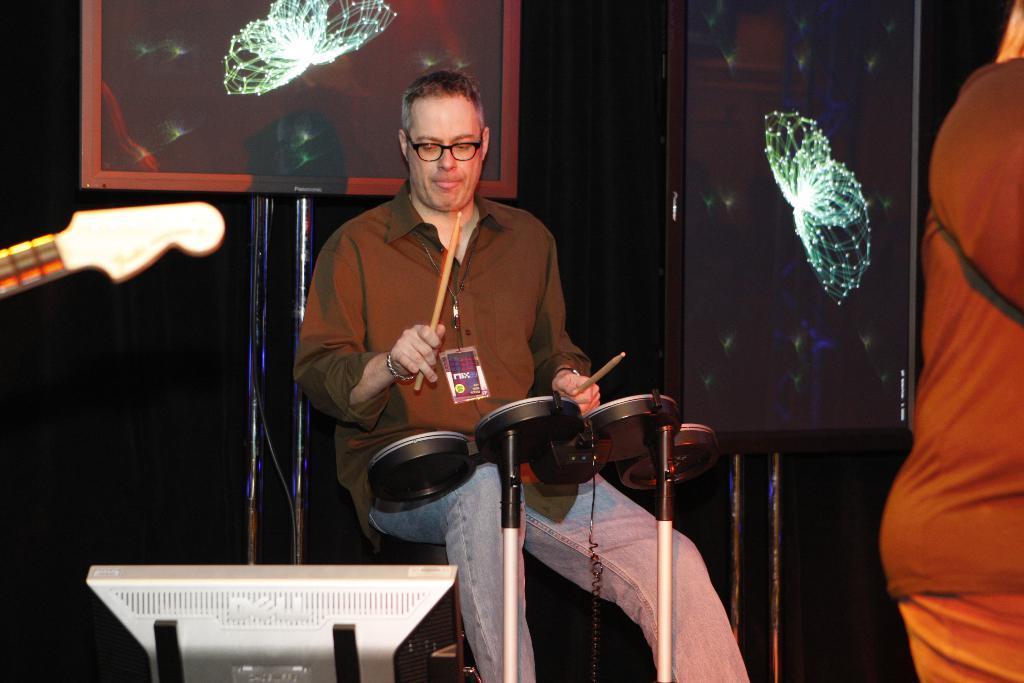In one or two sentences, can you explain what this image depicts? In this image I can see a person holding sticks and visible in front of musical instrument and I can see a stand in the middle and I can see a person on the right side and a black color board visible in the middle. 